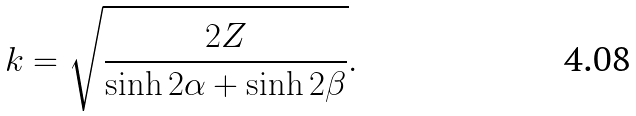<formula> <loc_0><loc_0><loc_500><loc_500>k = \sqrt { \frac { 2 Z } { \sinh 2 \alpha + \sinh 2 \beta } } .</formula> 